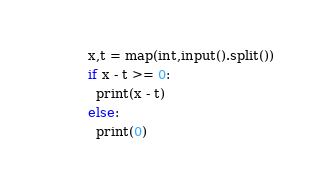Convert code to text. <code><loc_0><loc_0><loc_500><loc_500><_Python_>x,t = map(int,input().split())
if x - t >= 0:
  print(x - t)
else:
  print(0)</code> 